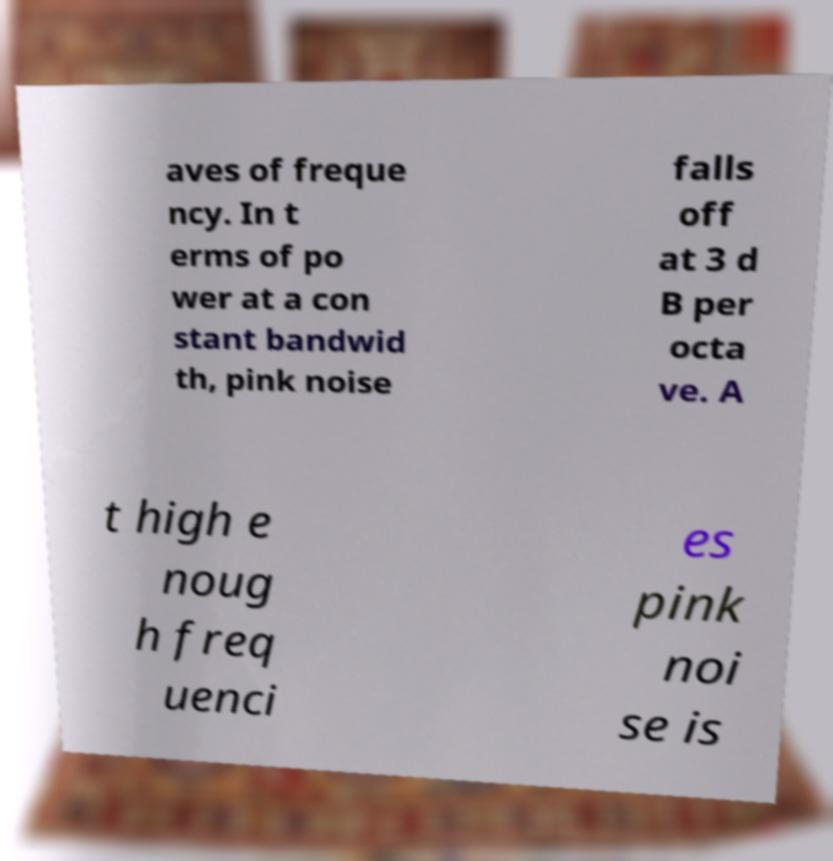For documentation purposes, I need the text within this image transcribed. Could you provide that? aves of freque ncy. In t erms of po wer at a con stant bandwid th, pink noise falls off at 3 d B per octa ve. A t high e noug h freq uenci es pink noi se is 